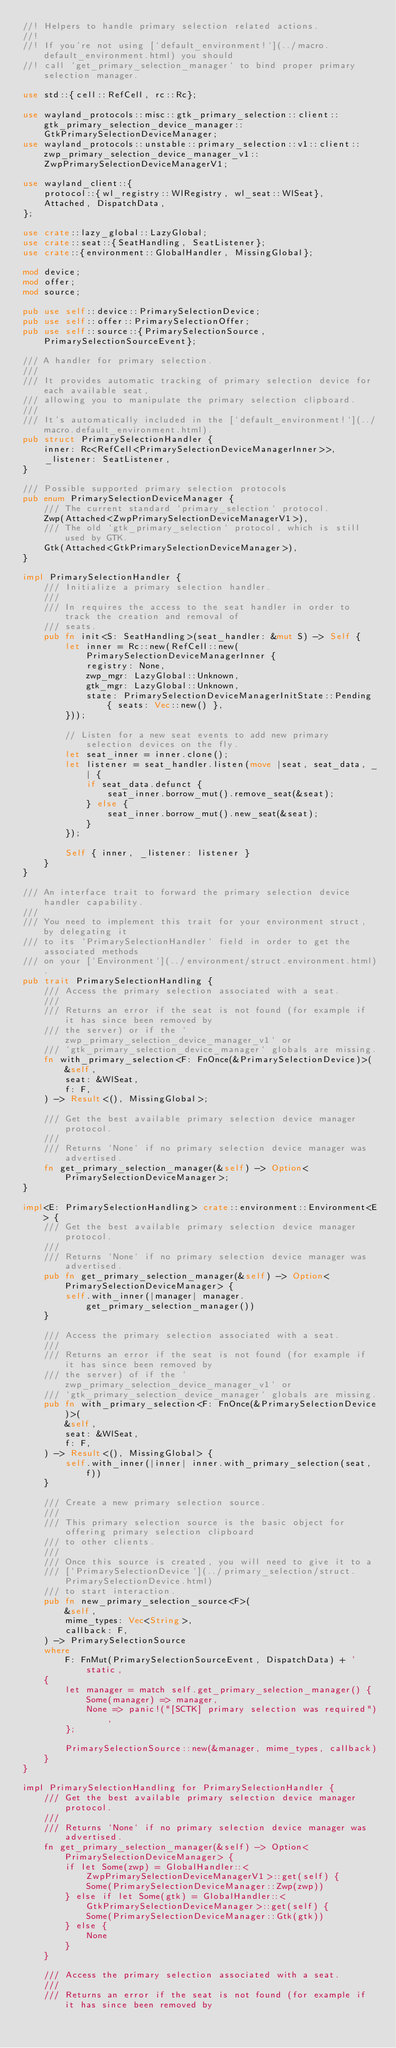<code> <loc_0><loc_0><loc_500><loc_500><_Rust_>//! Helpers to handle primary selection related actions.
//!
//! If you're not using [`default_environment!`](../macro.default_environment.html) you should
//! call `get_primary_selection_manager` to bind proper primary selection manager.

use std::{cell::RefCell, rc::Rc};

use wayland_protocols::misc::gtk_primary_selection::client::gtk_primary_selection_device_manager::GtkPrimarySelectionDeviceManager;
use wayland_protocols::unstable::primary_selection::v1::client::zwp_primary_selection_device_manager_v1::ZwpPrimarySelectionDeviceManagerV1;

use wayland_client::{
    protocol::{wl_registry::WlRegistry, wl_seat::WlSeat},
    Attached, DispatchData,
};

use crate::lazy_global::LazyGlobal;
use crate::seat::{SeatHandling, SeatListener};
use crate::{environment::GlobalHandler, MissingGlobal};

mod device;
mod offer;
mod source;

pub use self::device::PrimarySelectionDevice;
pub use self::offer::PrimarySelectionOffer;
pub use self::source::{PrimarySelectionSource, PrimarySelectionSourceEvent};

/// A handler for primary selection.
///
/// It provides automatic tracking of primary selection device for each available seat,
/// allowing you to manipulate the primary selection clipboard.
///
/// It's automatically included in the [`default_environment!`](../macro.default_environment.html).
pub struct PrimarySelectionHandler {
    inner: Rc<RefCell<PrimarySelectionDeviceManagerInner>>,
    _listener: SeatListener,
}

/// Possible supported primary selection protocols
pub enum PrimarySelectionDeviceManager {
    /// The current standard `primary_selection` protocol.
    Zwp(Attached<ZwpPrimarySelectionDeviceManagerV1>),
    /// The old `gtk_primary_selection` protocol, which is still used by GTK.
    Gtk(Attached<GtkPrimarySelectionDeviceManager>),
}

impl PrimarySelectionHandler {
    /// Initialize a primary selection handler.
    ///
    /// In requires the access to the seat handler in order to track the creation and removal of
    /// seats.
    pub fn init<S: SeatHandling>(seat_handler: &mut S) -> Self {
        let inner = Rc::new(RefCell::new(PrimarySelectionDeviceManagerInner {
            registry: None,
            zwp_mgr: LazyGlobal::Unknown,
            gtk_mgr: LazyGlobal::Unknown,
            state: PrimarySelectionDeviceManagerInitState::Pending { seats: Vec::new() },
        }));

        // Listen for a new seat events to add new primary selection devices on the fly.
        let seat_inner = inner.clone();
        let listener = seat_handler.listen(move |seat, seat_data, _| {
            if seat_data.defunct {
                seat_inner.borrow_mut().remove_seat(&seat);
            } else {
                seat_inner.borrow_mut().new_seat(&seat);
            }
        });

        Self { inner, _listener: listener }
    }
}

/// An interface trait to forward the primary selection device handler capability.
///
/// You need to implement this trait for your environment struct, by delegating it
/// to its `PrimarySelectionHandler` field in order to get the associated methods
/// on your [`Environment`](../environment/struct.environment.html).
pub trait PrimarySelectionHandling {
    /// Access the primary selection associated with a seat.
    ///
    /// Returns an error if the seat is not found (for example if it has since been removed by
    /// the server) or if the `zwp_primary_selection_device_manager_v1` or
    /// `gtk_primary_selection_device_manager` globals are missing.
    fn with_primary_selection<F: FnOnce(&PrimarySelectionDevice)>(
        &self,
        seat: &WlSeat,
        f: F,
    ) -> Result<(), MissingGlobal>;

    /// Get the best available primary selection device manager protocol.
    ///
    /// Returns `None` if no primary selection device manager was advertised.
    fn get_primary_selection_manager(&self) -> Option<PrimarySelectionDeviceManager>;
}

impl<E: PrimarySelectionHandling> crate::environment::Environment<E> {
    /// Get the best available primary selection device manager protocol.
    ///
    /// Returns `None` if no primary selection device manager was advertised.
    pub fn get_primary_selection_manager(&self) -> Option<PrimarySelectionDeviceManager> {
        self.with_inner(|manager| manager.get_primary_selection_manager())
    }

    /// Access the primary selection associated with a seat.
    ///
    /// Returns an error if the seat is not found (for example if it has since been removed by
    /// the server) of if the `zwp_primary_selection_device_manager_v1` or
    /// `gtk_primary_selection_device_manager` globals are missing.
    pub fn with_primary_selection<F: FnOnce(&PrimarySelectionDevice)>(
        &self,
        seat: &WlSeat,
        f: F,
    ) -> Result<(), MissingGlobal> {
        self.with_inner(|inner| inner.with_primary_selection(seat, f))
    }

    /// Create a new primary selection source.
    ///
    /// This primary selection source is the basic object for offering primary selection clipboard
    /// to other clients.
    ///
    /// Once this source is created, you will need to give it to a
    /// [`PrimarySelectionDevice`](../primary_selection/struct.PrimarySelectionDevice.html)
    /// to start interaction.
    pub fn new_primary_selection_source<F>(
        &self,
        mime_types: Vec<String>,
        callback: F,
    ) -> PrimarySelectionSource
    where
        F: FnMut(PrimarySelectionSourceEvent, DispatchData) + 'static,
    {
        let manager = match self.get_primary_selection_manager() {
            Some(manager) => manager,
            None => panic!("[SCTK] primary selection was required"),
        };

        PrimarySelectionSource::new(&manager, mime_types, callback)
    }
}

impl PrimarySelectionHandling for PrimarySelectionHandler {
    /// Get the best available primary selection device manager protocol.
    ///
    /// Returns `None` if no primary selection device manager was advertised.
    fn get_primary_selection_manager(&self) -> Option<PrimarySelectionDeviceManager> {
        if let Some(zwp) = GlobalHandler::<ZwpPrimarySelectionDeviceManagerV1>::get(self) {
            Some(PrimarySelectionDeviceManager::Zwp(zwp))
        } else if let Some(gtk) = GlobalHandler::<GtkPrimarySelectionDeviceManager>::get(self) {
            Some(PrimarySelectionDeviceManager::Gtk(gtk))
        } else {
            None
        }
    }

    /// Access the primary selection associated with a seat.
    ///
    /// Returns an error if the seat is not found (for example if it has since been removed by</code> 